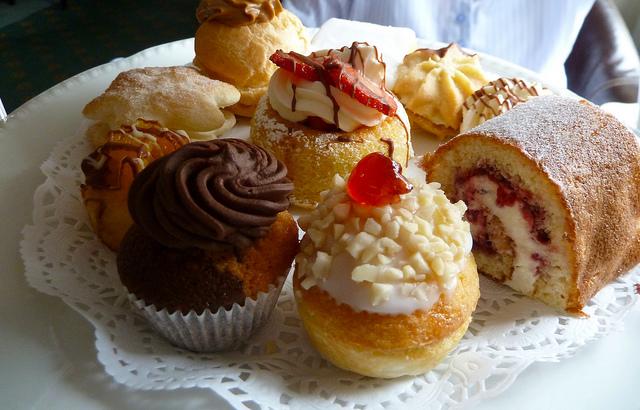What is sitting on the toilet?
Write a very short answer. Pastries. How many desserts are on the doily?
Write a very short answer. 9. Do any of the cupcakes have chocolate icing?
Short answer required. Yes. 